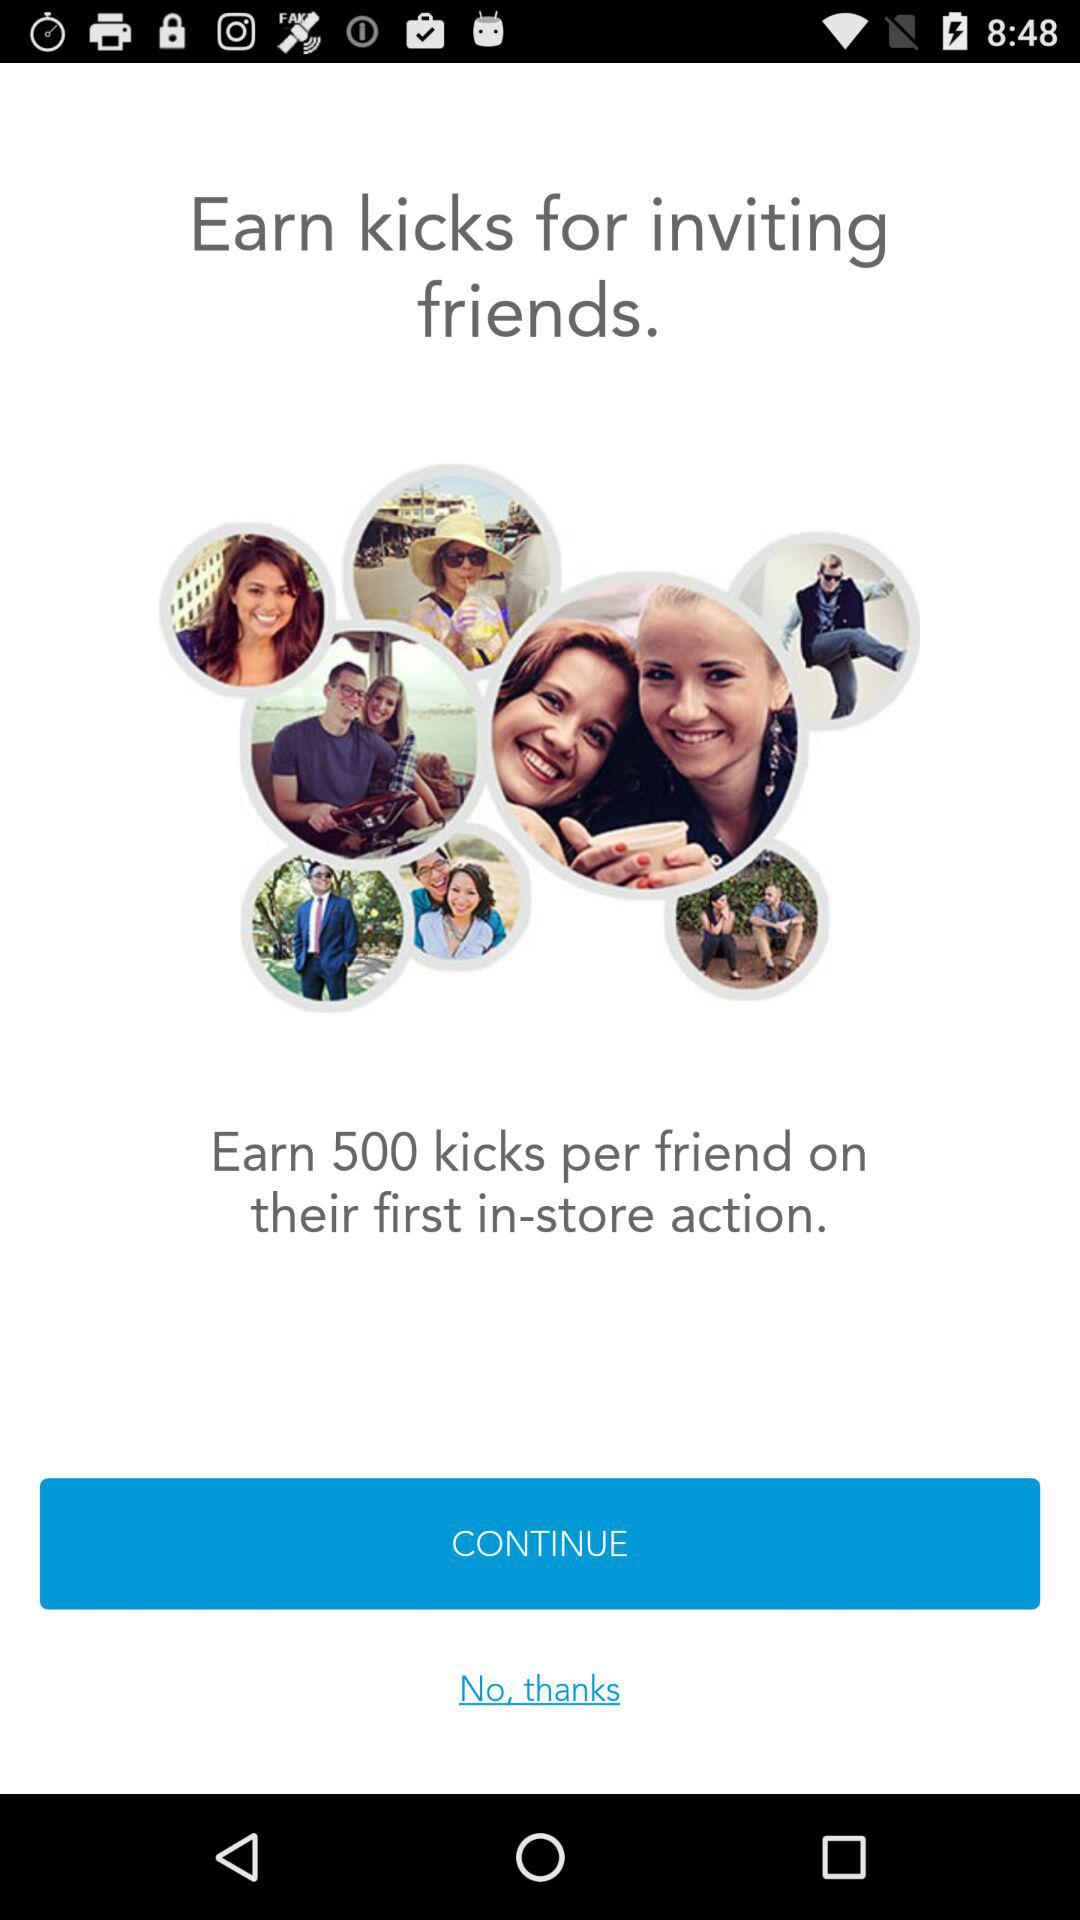Which stores can kicks be used in?
When the provided information is insufficient, respond with <no answer>. <no answer> 